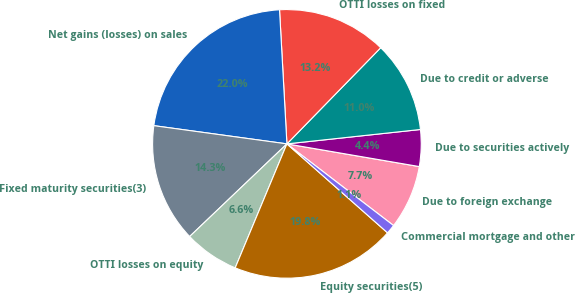Convert chart to OTSL. <chart><loc_0><loc_0><loc_500><loc_500><pie_chart><fcel>Due to foreign exchange<fcel>Due to securities actively<fcel>Due to credit or adverse<fcel>OTTI losses on fixed<fcel>Net gains (losses) on sales<fcel>Fixed maturity securities(3)<fcel>OTTI losses on equity<fcel>Equity securities(5)<fcel>Commercial mortgage and other<nl><fcel>7.7%<fcel>4.41%<fcel>10.99%<fcel>13.18%<fcel>21.96%<fcel>14.28%<fcel>6.6%<fcel>19.77%<fcel>1.12%<nl></chart> 